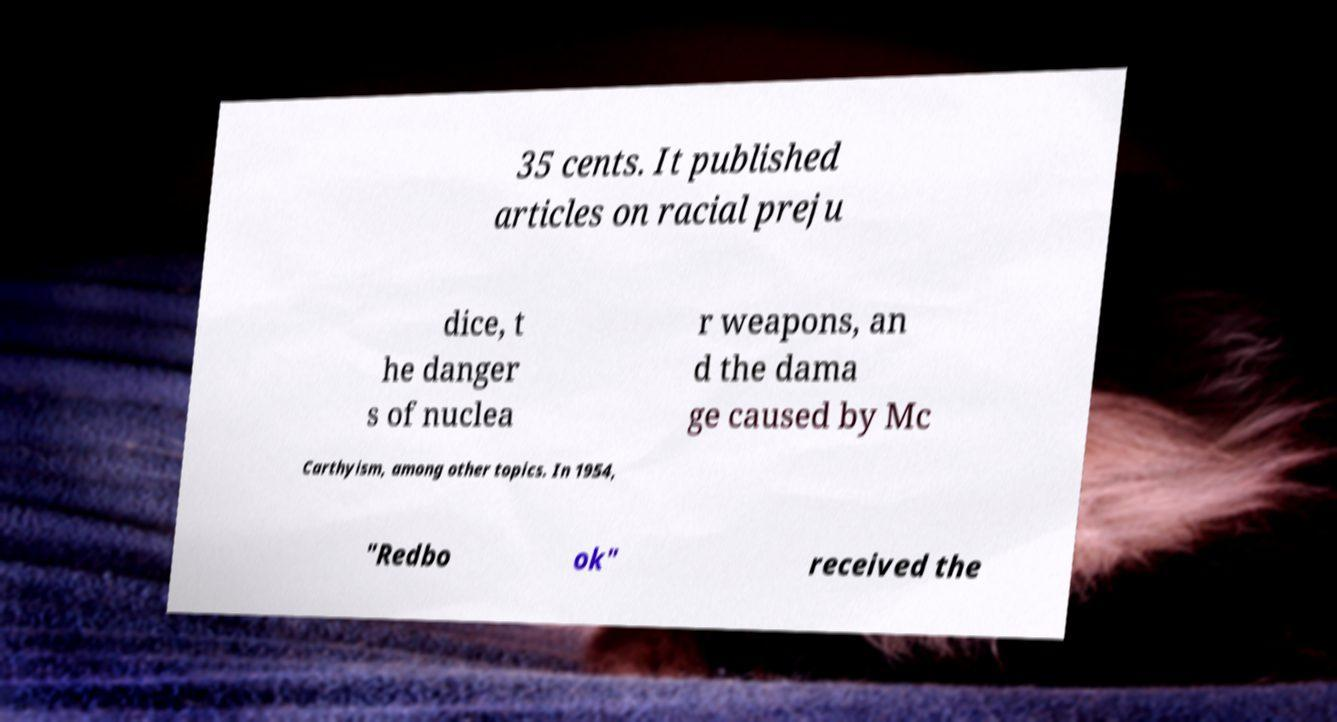Could you extract and type out the text from this image? 35 cents. It published articles on racial preju dice, t he danger s of nuclea r weapons, an d the dama ge caused by Mc Carthyism, among other topics. In 1954, "Redbo ok" received the 